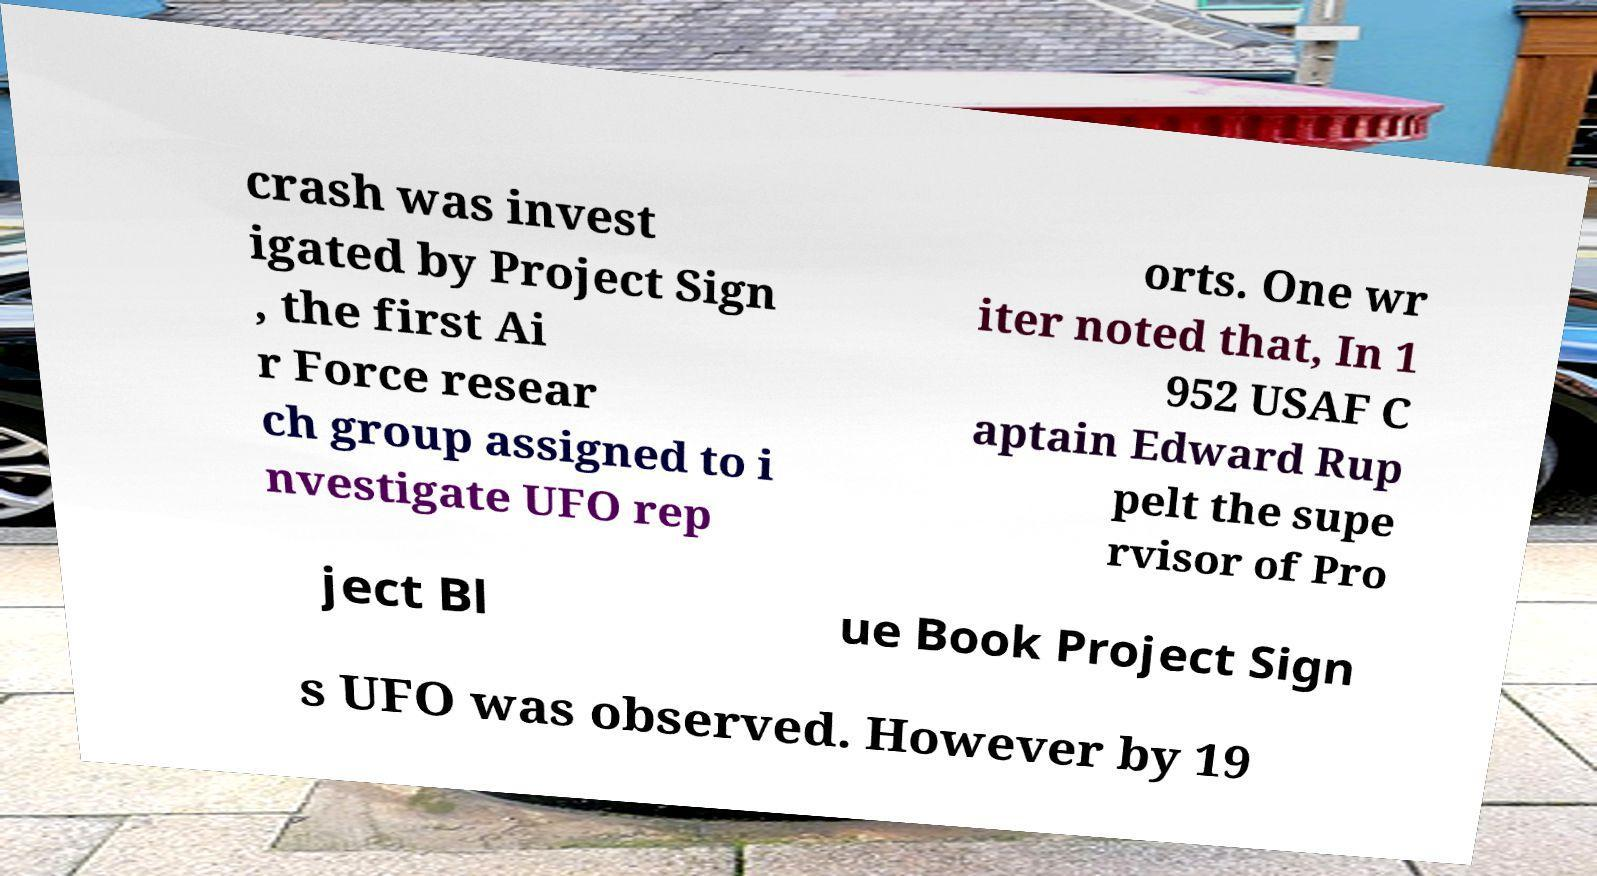Please identify and transcribe the text found in this image. crash was invest igated by Project Sign , the first Ai r Force resear ch group assigned to i nvestigate UFO rep orts. One wr iter noted that, In 1 952 USAF C aptain Edward Rup pelt the supe rvisor of Pro ject Bl ue Book Project Sign s UFO was observed. However by 19 